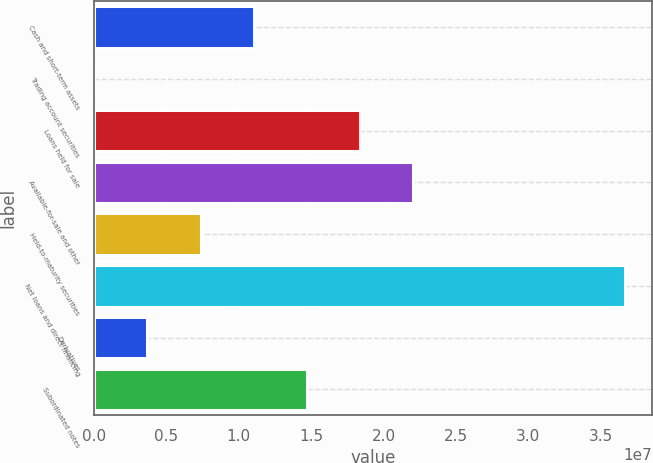<chart> <loc_0><loc_0><loc_500><loc_500><bar_chart><fcel>Cash and short-term assets<fcel>Trading account securities<fcel>Loans held for sale<fcel>Available-for-sale and other<fcel>Held-to-maturity securities<fcel>Net loans and direct financing<fcel>Derivatives<fcel>Subordinated notes<nl><fcel>1.10331e+07<fcel>45899<fcel>1.83579e+07<fcel>2.20203e+07<fcel>7.37068e+06<fcel>3.66698e+07<fcel>3.70829e+06<fcel>1.46955e+07<nl></chart> 